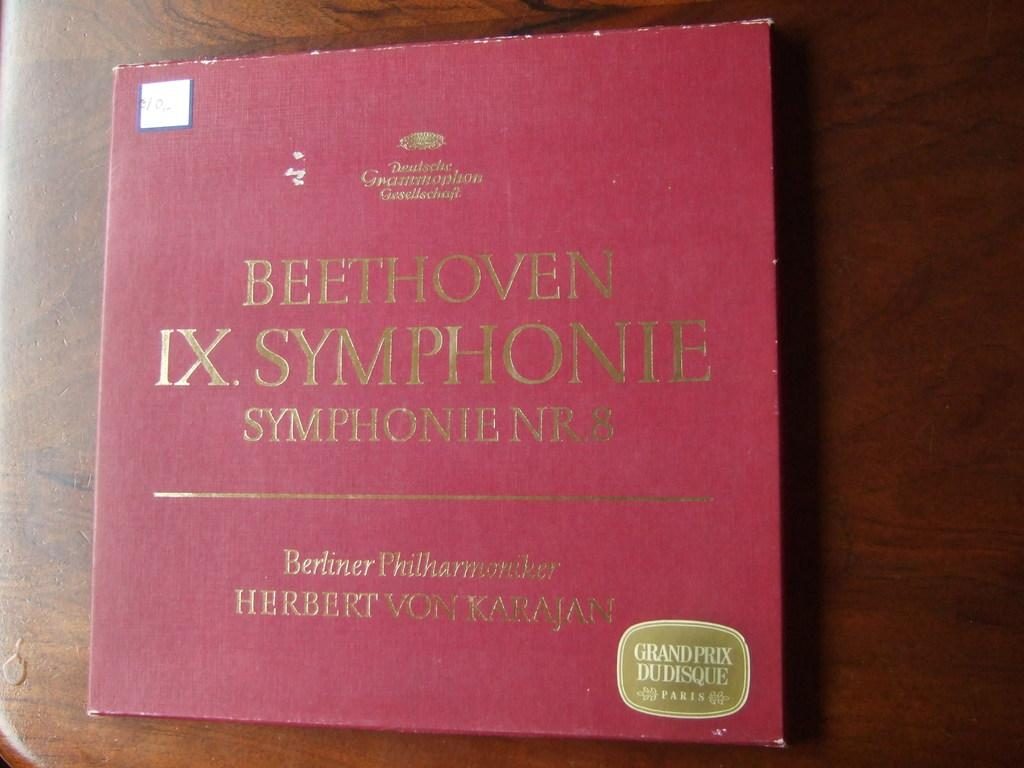<image>
Describe the image concisely. a red square has some of beethovens music inside 